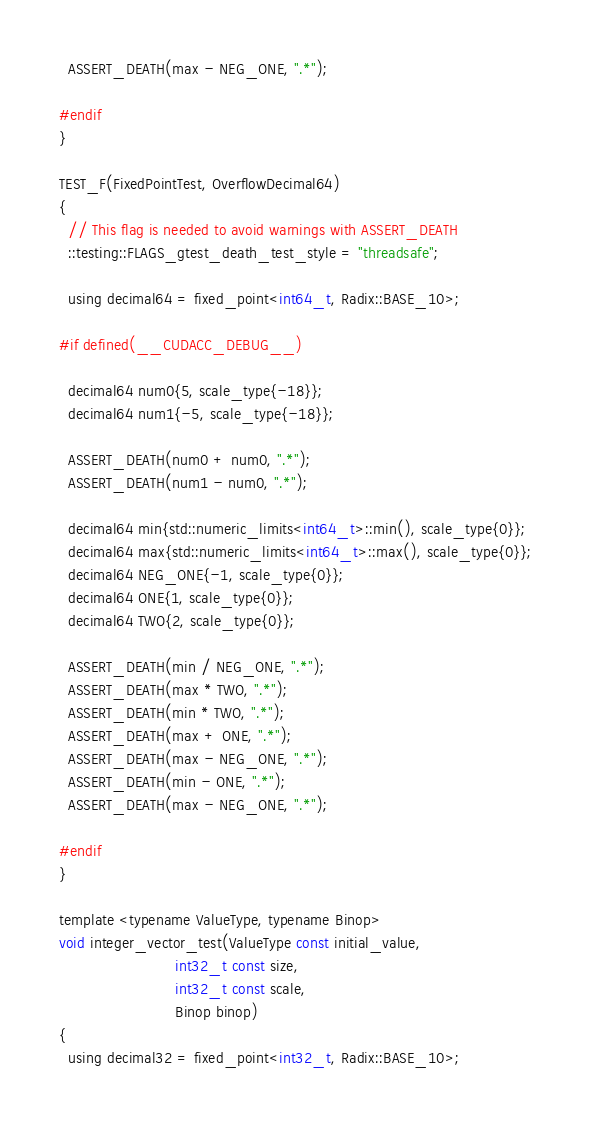<code> <loc_0><loc_0><loc_500><loc_500><_Cuda_>  ASSERT_DEATH(max - NEG_ONE, ".*");

#endif
}

TEST_F(FixedPointTest, OverflowDecimal64)
{
  // This flag is needed to avoid warnings with ASSERT_DEATH
  ::testing::FLAGS_gtest_death_test_style = "threadsafe";

  using decimal64 = fixed_point<int64_t, Radix::BASE_10>;

#if defined(__CUDACC_DEBUG__)

  decimal64 num0{5, scale_type{-18}};
  decimal64 num1{-5, scale_type{-18}};

  ASSERT_DEATH(num0 + num0, ".*");
  ASSERT_DEATH(num1 - num0, ".*");

  decimal64 min{std::numeric_limits<int64_t>::min(), scale_type{0}};
  decimal64 max{std::numeric_limits<int64_t>::max(), scale_type{0}};
  decimal64 NEG_ONE{-1, scale_type{0}};
  decimal64 ONE{1, scale_type{0}};
  decimal64 TWO{2, scale_type{0}};

  ASSERT_DEATH(min / NEG_ONE, ".*");
  ASSERT_DEATH(max * TWO, ".*");
  ASSERT_DEATH(min * TWO, ".*");
  ASSERT_DEATH(max + ONE, ".*");
  ASSERT_DEATH(max - NEG_ONE, ".*");
  ASSERT_DEATH(min - ONE, ".*");
  ASSERT_DEATH(max - NEG_ONE, ".*");

#endif
}

template <typename ValueType, typename Binop>
void integer_vector_test(ValueType const initial_value,
                         int32_t const size,
                         int32_t const scale,
                         Binop binop)
{
  using decimal32 = fixed_point<int32_t, Radix::BASE_10>;
</code> 